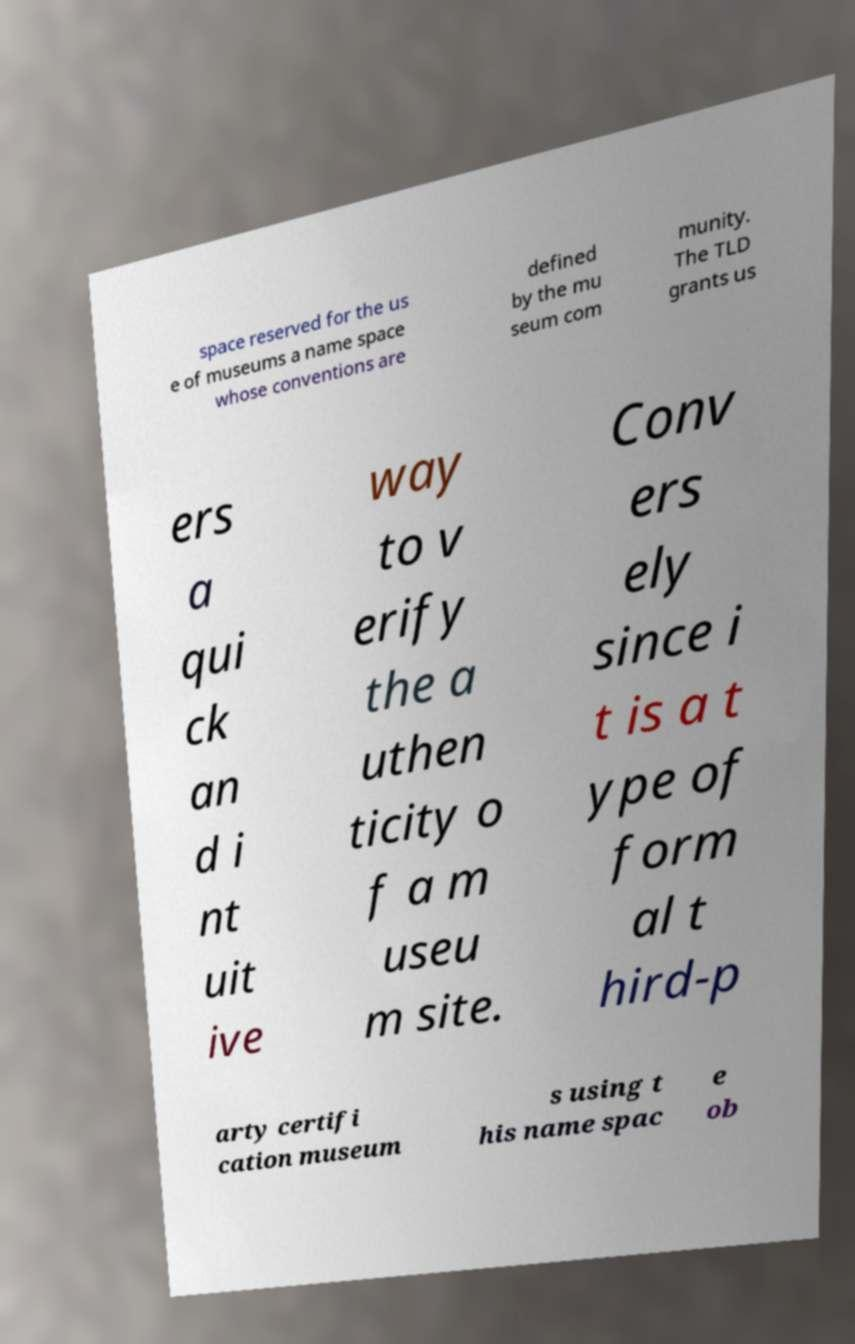There's text embedded in this image that I need extracted. Can you transcribe it verbatim? space reserved for the us e of museums a name space whose conventions are defined by the mu seum com munity. The TLD grants us ers a qui ck an d i nt uit ive way to v erify the a uthen ticity o f a m useu m site. Conv ers ely since i t is a t ype of form al t hird-p arty certifi cation museum s using t his name spac e ob 